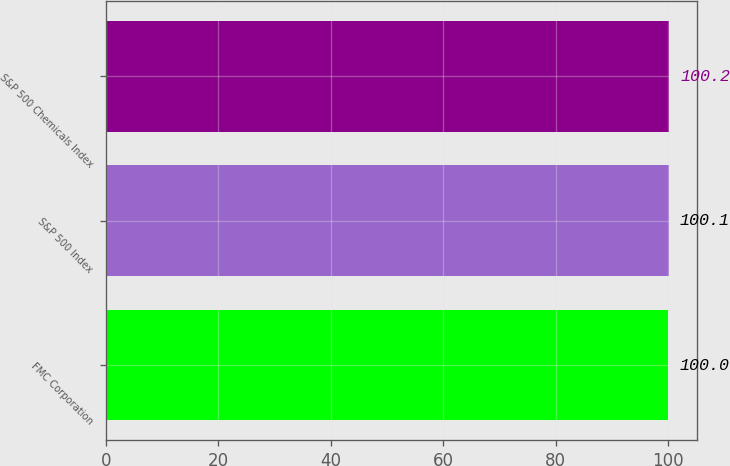Convert chart. <chart><loc_0><loc_0><loc_500><loc_500><bar_chart><fcel>FMC Corporation<fcel>S&P 500 Index<fcel>S&P 500 Chemicals Index<nl><fcel>100<fcel>100.1<fcel>100.2<nl></chart> 